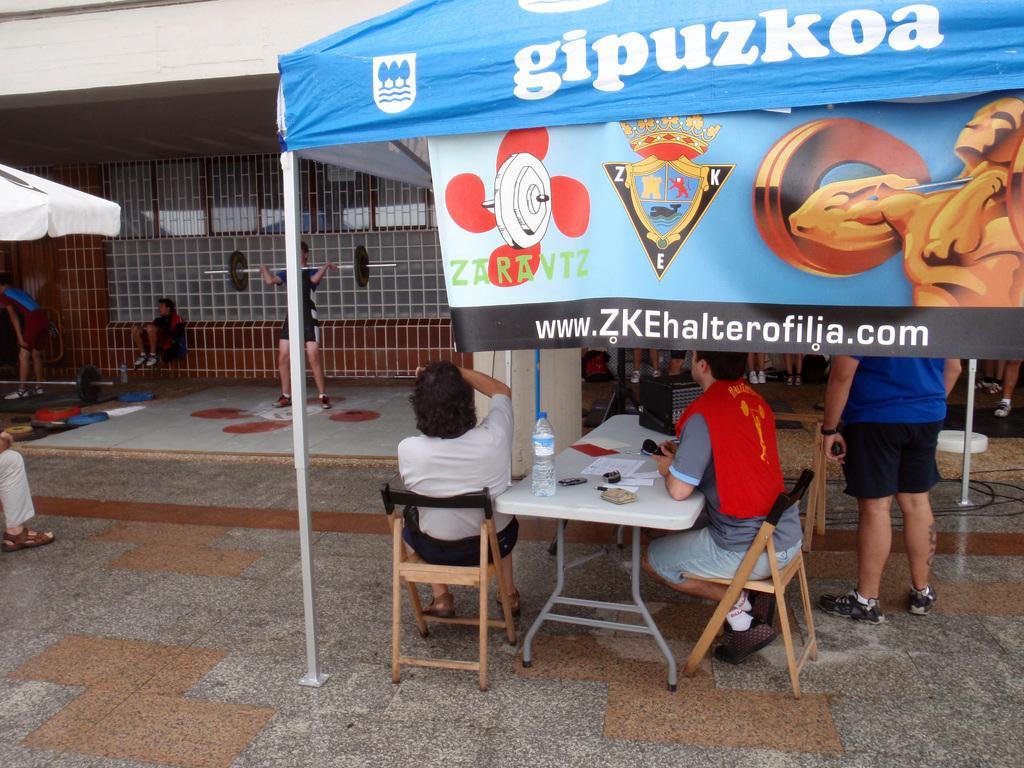Could you give a brief overview of what you see in this image? there are few people sitting and standing under a tent decide that there is a water bottle and papers on the table. 